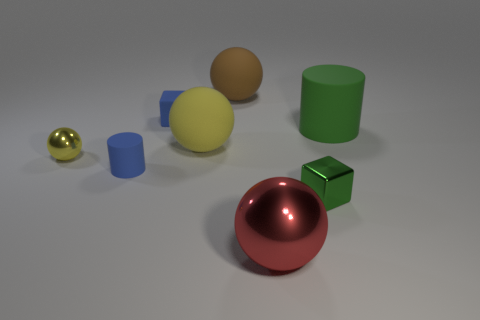How does the size of the small golden ball compare to that of the other objects? The small golden ball is the smallest object in the image when compared to the other geometric shapes, which are noticeably larger. 